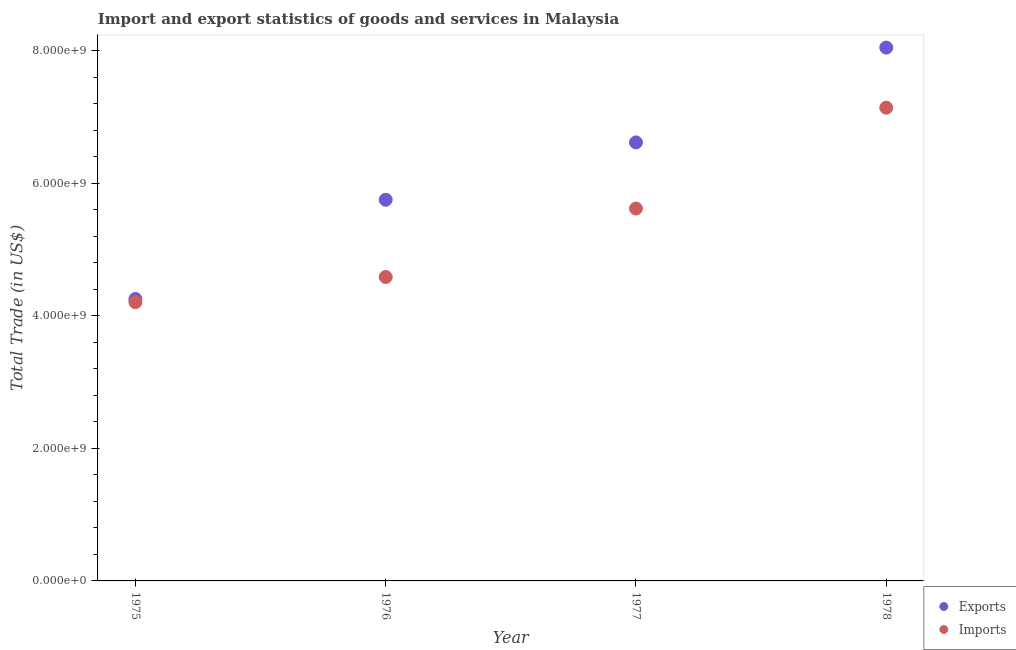What is the export of goods and services in 1978?
Give a very brief answer. 8.05e+09. Across all years, what is the maximum export of goods and services?
Give a very brief answer. 8.05e+09. Across all years, what is the minimum export of goods and services?
Make the answer very short. 4.26e+09. In which year was the imports of goods and services maximum?
Ensure brevity in your answer.  1978. In which year was the imports of goods and services minimum?
Provide a succinct answer. 1975. What is the total export of goods and services in the graph?
Your answer should be compact. 2.47e+1. What is the difference between the export of goods and services in 1977 and that in 1978?
Provide a succinct answer. -1.43e+09. What is the difference between the imports of goods and services in 1975 and the export of goods and services in 1977?
Ensure brevity in your answer.  -2.41e+09. What is the average export of goods and services per year?
Provide a succinct answer. 6.17e+09. In the year 1975, what is the difference between the export of goods and services and imports of goods and services?
Your response must be concise. 4.76e+07. In how many years, is the imports of goods and services greater than 1200000000 US$?
Your answer should be compact. 4. What is the ratio of the imports of goods and services in 1976 to that in 1978?
Offer a very short reply. 0.64. What is the difference between the highest and the second highest export of goods and services?
Offer a terse response. 1.43e+09. What is the difference between the highest and the lowest imports of goods and services?
Provide a succinct answer. 2.94e+09. Is the sum of the imports of goods and services in 1976 and 1978 greater than the maximum export of goods and services across all years?
Your answer should be very brief. Yes. Does the export of goods and services monotonically increase over the years?
Provide a short and direct response. Yes. Is the export of goods and services strictly less than the imports of goods and services over the years?
Your answer should be very brief. No. What is the difference between two consecutive major ticks on the Y-axis?
Give a very brief answer. 2.00e+09. Are the values on the major ticks of Y-axis written in scientific E-notation?
Your answer should be very brief. Yes. Does the graph contain any zero values?
Your answer should be compact. No. Does the graph contain grids?
Your answer should be compact. No. Where does the legend appear in the graph?
Your answer should be very brief. Bottom right. How are the legend labels stacked?
Provide a succinct answer. Vertical. What is the title of the graph?
Offer a terse response. Import and export statistics of goods and services in Malaysia. Does "Diesel" appear as one of the legend labels in the graph?
Offer a terse response. No. What is the label or title of the X-axis?
Your answer should be compact. Year. What is the label or title of the Y-axis?
Provide a succinct answer. Total Trade (in US$). What is the Total Trade (in US$) of Exports in 1975?
Your answer should be very brief. 4.26e+09. What is the Total Trade (in US$) in Imports in 1975?
Ensure brevity in your answer.  4.21e+09. What is the Total Trade (in US$) in Exports in 1976?
Provide a succinct answer. 5.75e+09. What is the Total Trade (in US$) in Imports in 1976?
Your answer should be compact. 4.59e+09. What is the Total Trade (in US$) of Exports in 1977?
Keep it short and to the point. 6.62e+09. What is the Total Trade (in US$) of Imports in 1977?
Keep it short and to the point. 5.62e+09. What is the Total Trade (in US$) of Exports in 1978?
Ensure brevity in your answer.  8.05e+09. What is the Total Trade (in US$) in Imports in 1978?
Your answer should be very brief. 7.14e+09. Across all years, what is the maximum Total Trade (in US$) in Exports?
Ensure brevity in your answer.  8.05e+09. Across all years, what is the maximum Total Trade (in US$) in Imports?
Your response must be concise. 7.14e+09. Across all years, what is the minimum Total Trade (in US$) of Exports?
Keep it short and to the point. 4.26e+09. Across all years, what is the minimum Total Trade (in US$) in Imports?
Offer a very short reply. 4.21e+09. What is the total Total Trade (in US$) of Exports in the graph?
Offer a terse response. 2.47e+1. What is the total Total Trade (in US$) of Imports in the graph?
Your response must be concise. 2.16e+1. What is the difference between the Total Trade (in US$) of Exports in 1975 and that in 1976?
Provide a short and direct response. -1.50e+09. What is the difference between the Total Trade (in US$) in Imports in 1975 and that in 1976?
Your response must be concise. -3.80e+08. What is the difference between the Total Trade (in US$) of Exports in 1975 and that in 1977?
Provide a succinct answer. -2.36e+09. What is the difference between the Total Trade (in US$) in Imports in 1975 and that in 1977?
Your response must be concise. -1.41e+09. What is the difference between the Total Trade (in US$) in Exports in 1975 and that in 1978?
Give a very brief answer. -3.79e+09. What is the difference between the Total Trade (in US$) in Imports in 1975 and that in 1978?
Your response must be concise. -2.94e+09. What is the difference between the Total Trade (in US$) in Exports in 1976 and that in 1977?
Make the answer very short. -8.66e+08. What is the difference between the Total Trade (in US$) in Imports in 1976 and that in 1977?
Keep it short and to the point. -1.03e+09. What is the difference between the Total Trade (in US$) in Exports in 1976 and that in 1978?
Provide a succinct answer. -2.30e+09. What is the difference between the Total Trade (in US$) of Imports in 1976 and that in 1978?
Offer a terse response. -2.56e+09. What is the difference between the Total Trade (in US$) in Exports in 1977 and that in 1978?
Provide a short and direct response. -1.43e+09. What is the difference between the Total Trade (in US$) of Imports in 1977 and that in 1978?
Offer a very short reply. -1.52e+09. What is the difference between the Total Trade (in US$) in Exports in 1975 and the Total Trade (in US$) in Imports in 1976?
Provide a short and direct response. -3.32e+08. What is the difference between the Total Trade (in US$) of Exports in 1975 and the Total Trade (in US$) of Imports in 1977?
Keep it short and to the point. -1.37e+09. What is the difference between the Total Trade (in US$) of Exports in 1975 and the Total Trade (in US$) of Imports in 1978?
Offer a terse response. -2.89e+09. What is the difference between the Total Trade (in US$) in Exports in 1976 and the Total Trade (in US$) in Imports in 1977?
Ensure brevity in your answer.  1.32e+08. What is the difference between the Total Trade (in US$) in Exports in 1976 and the Total Trade (in US$) in Imports in 1978?
Make the answer very short. -1.39e+09. What is the difference between the Total Trade (in US$) of Exports in 1977 and the Total Trade (in US$) of Imports in 1978?
Offer a terse response. -5.24e+08. What is the average Total Trade (in US$) of Exports per year?
Your answer should be very brief. 6.17e+09. What is the average Total Trade (in US$) in Imports per year?
Ensure brevity in your answer.  5.39e+09. In the year 1975, what is the difference between the Total Trade (in US$) of Exports and Total Trade (in US$) of Imports?
Make the answer very short. 4.76e+07. In the year 1976, what is the difference between the Total Trade (in US$) in Exports and Total Trade (in US$) in Imports?
Your response must be concise. 1.17e+09. In the year 1977, what is the difference between the Total Trade (in US$) of Exports and Total Trade (in US$) of Imports?
Keep it short and to the point. 9.98e+08. In the year 1978, what is the difference between the Total Trade (in US$) in Exports and Total Trade (in US$) in Imports?
Your response must be concise. 9.07e+08. What is the ratio of the Total Trade (in US$) of Exports in 1975 to that in 1976?
Your answer should be compact. 0.74. What is the ratio of the Total Trade (in US$) of Imports in 1975 to that in 1976?
Ensure brevity in your answer.  0.92. What is the ratio of the Total Trade (in US$) of Exports in 1975 to that in 1977?
Keep it short and to the point. 0.64. What is the ratio of the Total Trade (in US$) of Imports in 1975 to that in 1977?
Your response must be concise. 0.75. What is the ratio of the Total Trade (in US$) in Exports in 1975 to that in 1978?
Your answer should be compact. 0.53. What is the ratio of the Total Trade (in US$) of Imports in 1975 to that in 1978?
Your answer should be very brief. 0.59. What is the ratio of the Total Trade (in US$) of Exports in 1976 to that in 1977?
Make the answer very short. 0.87. What is the ratio of the Total Trade (in US$) of Imports in 1976 to that in 1977?
Provide a short and direct response. 0.82. What is the ratio of the Total Trade (in US$) in Exports in 1976 to that in 1978?
Make the answer very short. 0.71. What is the ratio of the Total Trade (in US$) of Imports in 1976 to that in 1978?
Your response must be concise. 0.64. What is the ratio of the Total Trade (in US$) of Exports in 1977 to that in 1978?
Offer a very short reply. 0.82. What is the ratio of the Total Trade (in US$) of Imports in 1977 to that in 1978?
Ensure brevity in your answer.  0.79. What is the difference between the highest and the second highest Total Trade (in US$) in Exports?
Offer a very short reply. 1.43e+09. What is the difference between the highest and the second highest Total Trade (in US$) of Imports?
Your answer should be compact. 1.52e+09. What is the difference between the highest and the lowest Total Trade (in US$) in Exports?
Provide a succinct answer. 3.79e+09. What is the difference between the highest and the lowest Total Trade (in US$) in Imports?
Ensure brevity in your answer.  2.94e+09. 